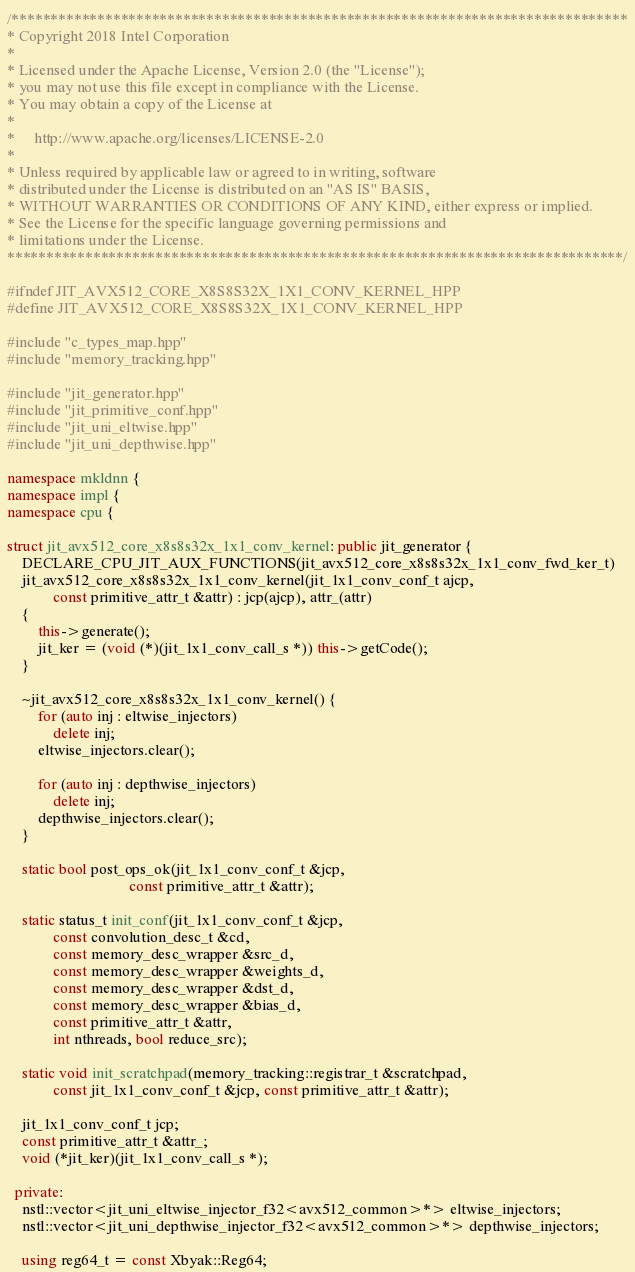Convert code to text. <code><loc_0><loc_0><loc_500><loc_500><_C++_>/*******************************************************************************
* Copyright 2018 Intel Corporation
*
* Licensed under the Apache License, Version 2.0 (the "License");
* you may not use this file except in compliance with the License.
* You may obtain a copy of the License at
*
*     http://www.apache.org/licenses/LICENSE-2.0
*
* Unless required by applicable law or agreed to in writing, software
* distributed under the License is distributed on an "AS IS" BASIS,
* WITHOUT WARRANTIES OR CONDITIONS OF ANY KIND, either express or implied.
* See the License for the specific language governing permissions and
* limitations under the License.
*******************************************************************************/

#ifndef JIT_AVX512_CORE_X8S8S32X_1X1_CONV_KERNEL_HPP
#define JIT_AVX512_CORE_X8S8S32X_1X1_CONV_KERNEL_HPP

#include "c_types_map.hpp"
#include "memory_tracking.hpp"

#include "jit_generator.hpp"
#include "jit_primitive_conf.hpp"
#include "jit_uni_eltwise.hpp"
#include "jit_uni_depthwise.hpp"

namespace mkldnn {
namespace impl {
namespace cpu {

struct jit_avx512_core_x8s8s32x_1x1_conv_kernel: public jit_generator {
    DECLARE_CPU_JIT_AUX_FUNCTIONS(jit_avx512_core_x8s8s32x_1x1_conv_fwd_ker_t)
    jit_avx512_core_x8s8s32x_1x1_conv_kernel(jit_1x1_conv_conf_t ajcp,
            const primitive_attr_t &attr) : jcp(ajcp), attr_(attr)
    {
        this->generate();
        jit_ker = (void (*)(jit_1x1_conv_call_s *)) this->getCode();
    }

    ~jit_avx512_core_x8s8s32x_1x1_conv_kernel() {
        for (auto inj : eltwise_injectors)
            delete inj;
        eltwise_injectors.clear();

        for (auto inj : depthwise_injectors)
            delete inj;
        depthwise_injectors.clear();
    }

    static bool post_ops_ok(jit_1x1_conv_conf_t &jcp,
                                const primitive_attr_t &attr);

    static status_t init_conf(jit_1x1_conv_conf_t &jcp,
            const convolution_desc_t &cd,
            const memory_desc_wrapper &src_d,
            const memory_desc_wrapper &weights_d,
            const memory_desc_wrapper &dst_d,
            const memory_desc_wrapper &bias_d,
            const primitive_attr_t &attr,
            int nthreads, bool reduce_src);

    static void init_scratchpad(memory_tracking::registrar_t &scratchpad,
            const jit_1x1_conv_conf_t &jcp, const primitive_attr_t &attr);

    jit_1x1_conv_conf_t jcp;
    const primitive_attr_t &attr_;
    void (*jit_ker)(jit_1x1_conv_call_s *);

  private:
    nstl::vector<jit_uni_eltwise_injector_f32<avx512_common>*> eltwise_injectors;
    nstl::vector<jit_uni_depthwise_injector_f32<avx512_common>*> depthwise_injectors;

    using reg64_t = const Xbyak::Reg64;</code> 